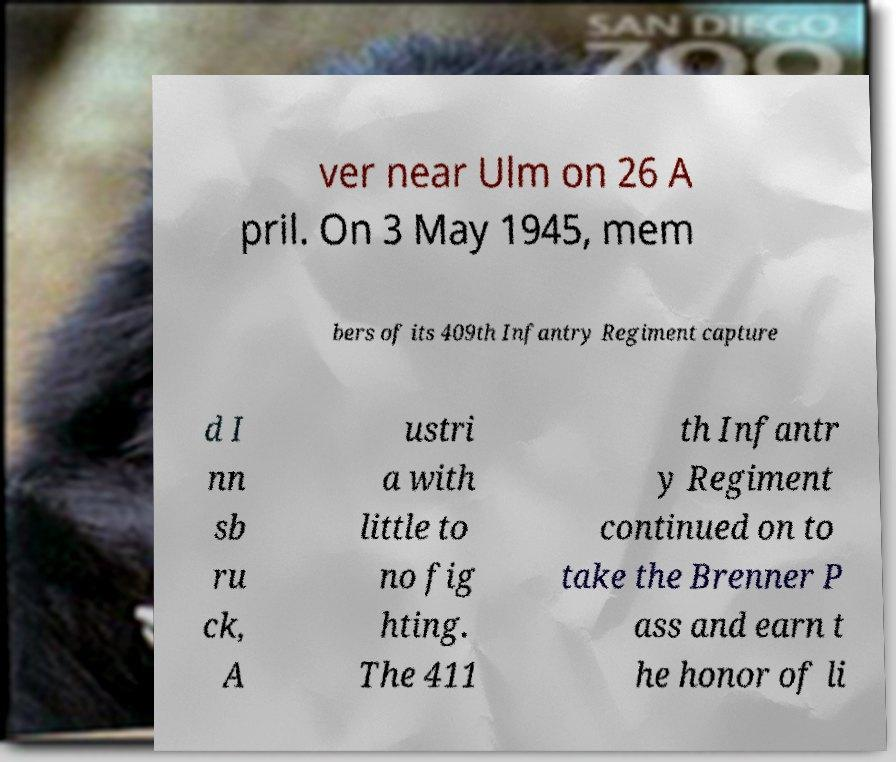Could you assist in decoding the text presented in this image and type it out clearly? ver near Ulm on 26 A pril. On 3 May 1945, mem bers of its 409th Infantry Regiment capture d I nn sb ru ck, A ustri a with little to no fig hting. The 411 th Infantr y Regiment continued on to take the Brenner P ass and earn t he honor of li 